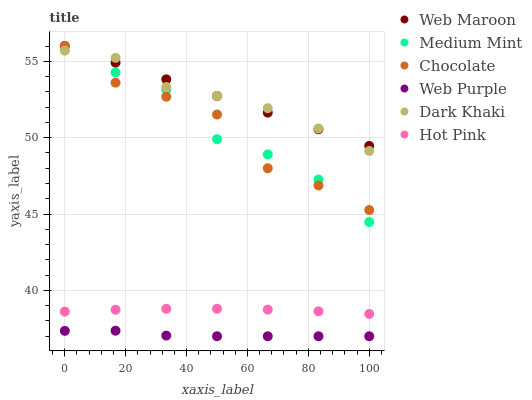Does Web Purple have the minimum area under the curve?
Answer yes or no. Yes. Does Web Maroon have the maximum area under the curve?
Answer yes or no. Yes. Does Hot Pink have the minimum area under the curve?
Answer yes or no. No. Does Hot Pink have the maximum area under the curve?
Answer yes or no. No. Is Web Maroon the smoothest?
Answer yes or no. Yes. Is Chocolate the roughest?
Answer yes or no. Yes. Is Hot Pink the smoothest?
Answer yes or no. No. Is Hot Pink the roughest?
Answer yes or no. No. Does Web Purple have the lowest value?
Answer yes or no. Yes. Does Hot Pink have the lowest value?
Answer yes or no. No. Does Chocolate have the highest value?
Answer yes or no. Yes. Does Hot Pink have the highest value?
Answer yes or no. No. Is Hot Pink less than Dark Khaki?
Answer yes or no. Yes. Is Chocolate greater than Hot Pink?
Answer yes or no. Yes. Does Dark Khaki intersect Web Maroon?
Answer yes or no. Yes. Is Dark Khaki less than Web Maroon?
Answer yes or no. No. Is Dark Khaki greater than Web Maroon?
Answer yes or no. No. Does Hot Pink intersect Dark Khaki?
Answer yes or no. No. 